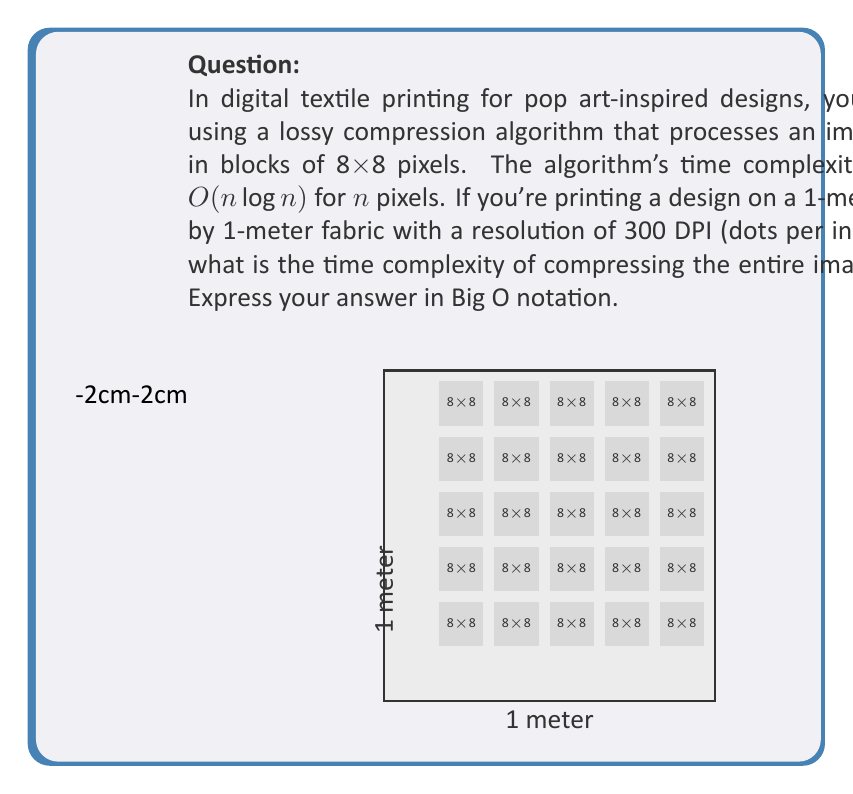Solve this math problem. Let's approach this step-by-step:

1) First, we need to calculate the total number of pixels in the image:
   - 1 meter = 39.37 inches
   - At 300 DPI, we have 300 * 39.37 = 11,811 pixels per side (rounded down)
   - Total pixels = $11,811^2 = 139,499,721$

2) Let's call this number $N$. So $N = 139,499,721$ pixels.

3) The algorithm processes the image in 8x8 blocks. Let's calculate how many blocks we have:
   - Number of blocks = $N / 64$ (since each block is 8x8 = 64 pixels)
   - Number of blocks = $139,499,721 / 64 = 2,179,683$ (rounded down)

4) Let's call the number of blocks $m$. So $m = 2,179,683$.

5) For each block, the algorithm's time complexity is $O(64 \log 64)$, since each block has 64 pixels.

6) We need to process $m$ blocks, so the total time complexity is:
   $O(m * 64 \log 64)$

7) Simplify:
   $O(m * 64 \log 64) = O(64m \log 64) = O(m)$ (since 64 and $\log 64$ are constants)

8) Substitute back $m$ in terms of $N$:
   $O(m) = O(N/64) = O(N)$

Therefore, the overall time complexity is $O(N)$, where $N$ is the total number of pixels in the image.
Answer: $O(N)$, where $N$ is the total number of pixels 